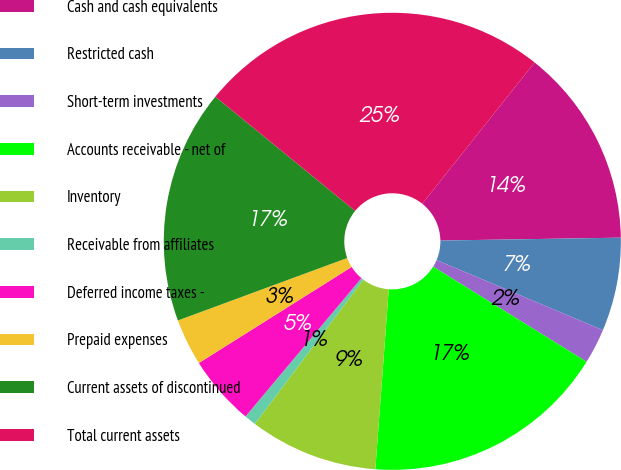Convert chart. <chart><loc_0><loc_0><loc_500><loc_500><pie_chart><fcel>Cash and cash equivalents<fcel>Restricted cash<fcel>Short-term investments<fcel>Accounts receivable - net of<fcel>Inventory<fcel>Receivable from affiliates<fcel>Deferred income taxes -<fcel>Prepaid expenses<fcel>Current assets of discontinued<fcel>Total current assets<nl><fcel>14.05%<fcel>6.61%<fcel>2.48%<fcel>17.35%<fcel>9.09%<fcel>0.83%<fcel>4.96%<fcel>3.31%<fcel>16.53%<fcel>24.79%<nl></chart> 